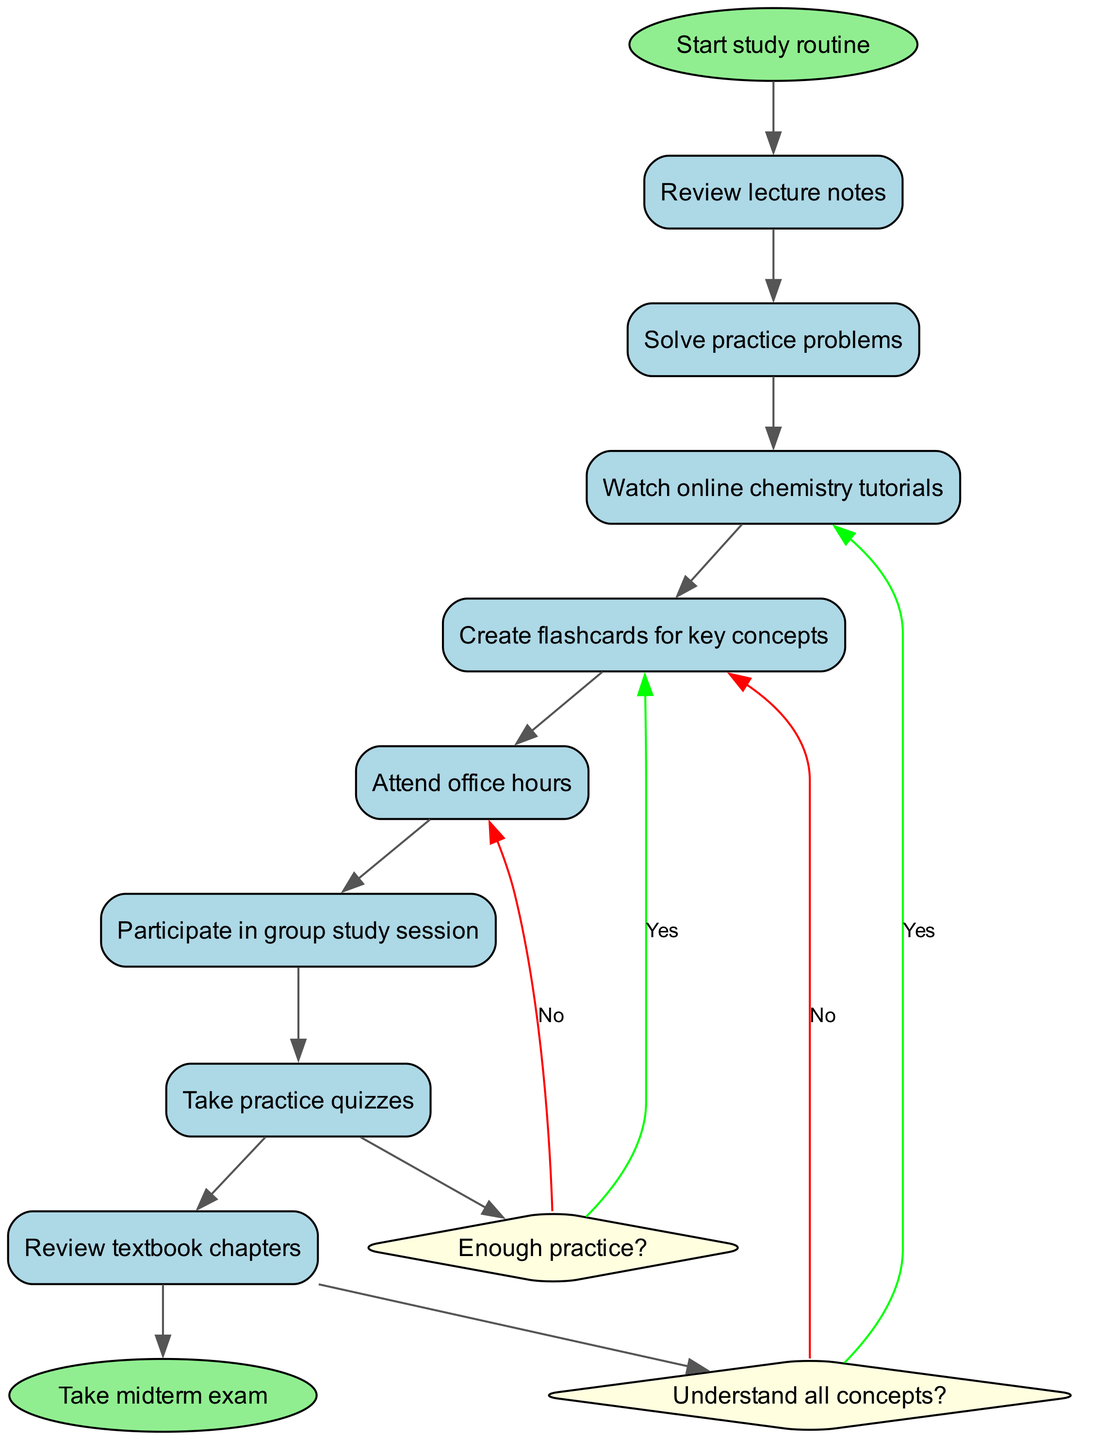What is the initial node in the diagram? The initial node is designated as the starting point of the study routine, and it is mentioned in the data as "Start study routine."
Answer: Start study routine How many activities are there in total? By counting the items in the activities list, we find there are 8 different activities outlined in the study routine.
Answer: 8 What is the final node in the diagram? The final node signifies the completion of the study routine, which is defined in the data as "Take midterm exam."
Answer: Take midterm exam What decision follows the activity "Solve practice problems"? The decision that follows the "Solve practice problems" activity is the question "Understand all concepts?" which is directly related to assessing the student's comprehension.
Answer: Understand all concepts? What happens if the answer to "Enough practice?" is yes? If the answer to "Enough practice?" is yes, the routine directs you to "Review weak areas," indicating that it encourages targeted study to improve understanding further.
Answer: Review weak areas What is the outcome if the answer to "Understand all concepts?" is no? Following the decision where the answer is no to "Understand all concepts?", the next action would be to "Seek clarification," which implies getting help to grasp the concepts better.
Answer: Seek clarification Which two activities point to the decision node "Enough practice?" The two activities that point to the decision node "Enough practice?" are "Review textbook chapters" and "Take practice quizzes," indicating a flow towards evaluating the adequacy of practice efforts.
Answer: Review textbook chapters, Take practice quizzes Where does the activity "Attend office hours" fit in the flow of the routine? The "Attend office hours" activity does not lead to any decision or subsequent activity and instead flows toward the decision node indirectly, suggesting it is a supplementary action to clarify concepts at any point.
Answer: Decision node How many decision nodes are in the diagram? The diagram contains a total of 2 decision nodes, each addressing different questions to help guide the study process.
Answer: 2 